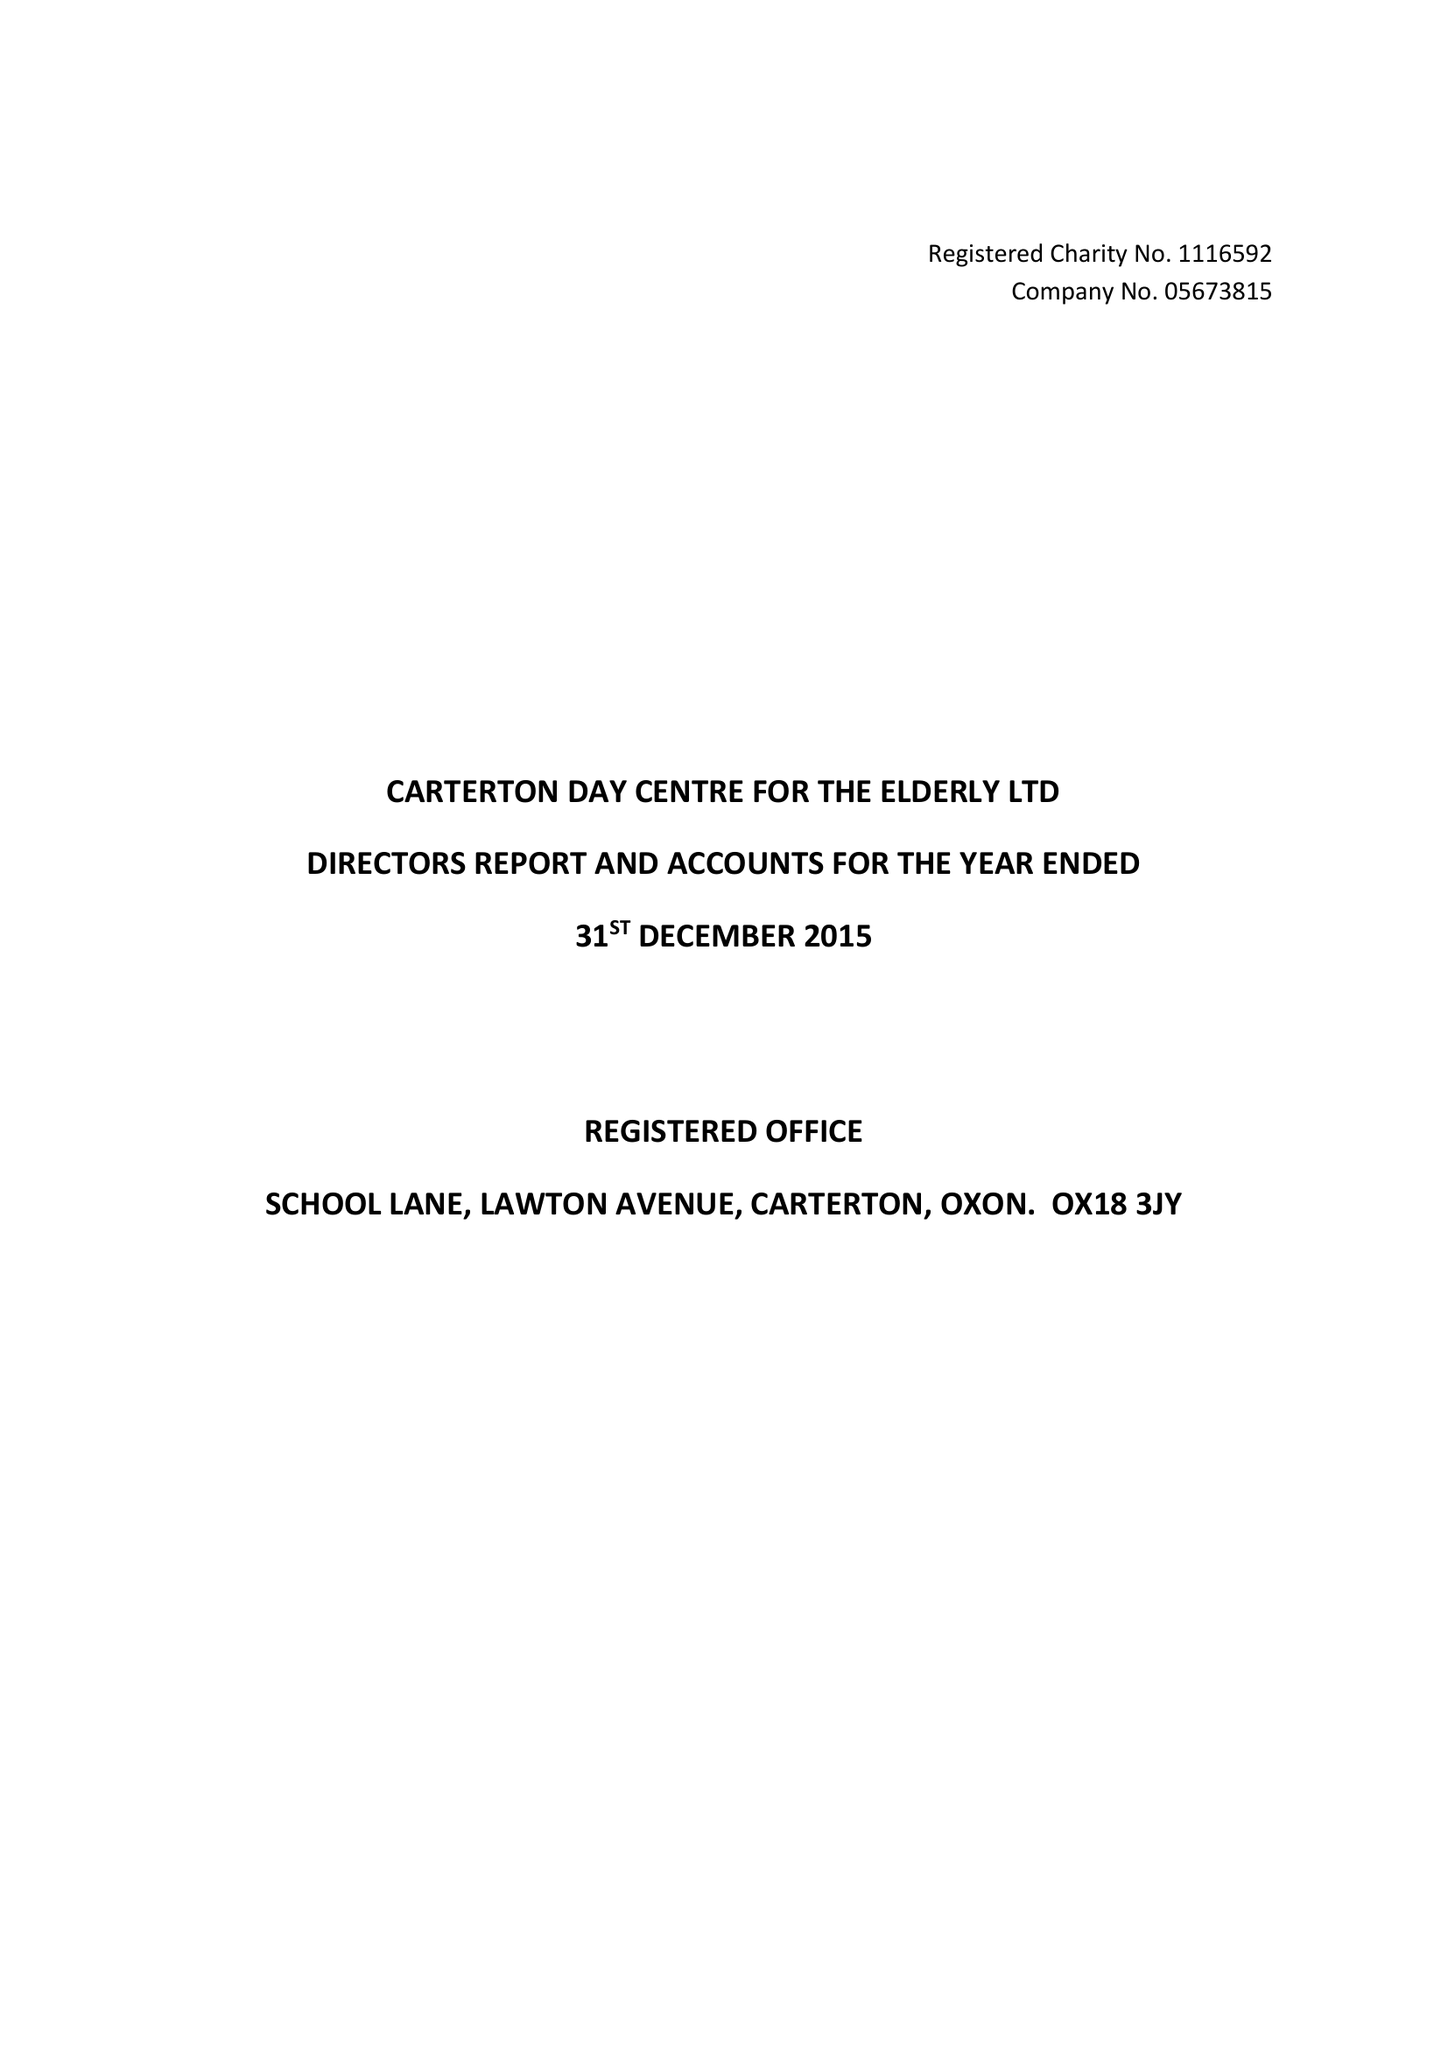What is the value for the charity_number?
Answer the question using a single word or phrase. 1116592 